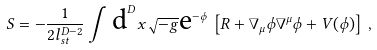<formula> <loc_0><loc_0><loc_500><loc_500>S = - \frac { 1 } { 2 l _ { s t } ^ { D - 2 } } \int \, \mbox d ^ { D } x \sqrt { - g } \mbox e ^ { - \phi } \, \left [ R + \nabla _ { \mu } \phi \nabla ^ { \mu } \phi + V ( \phi ) \right ] \, ,</formula> 